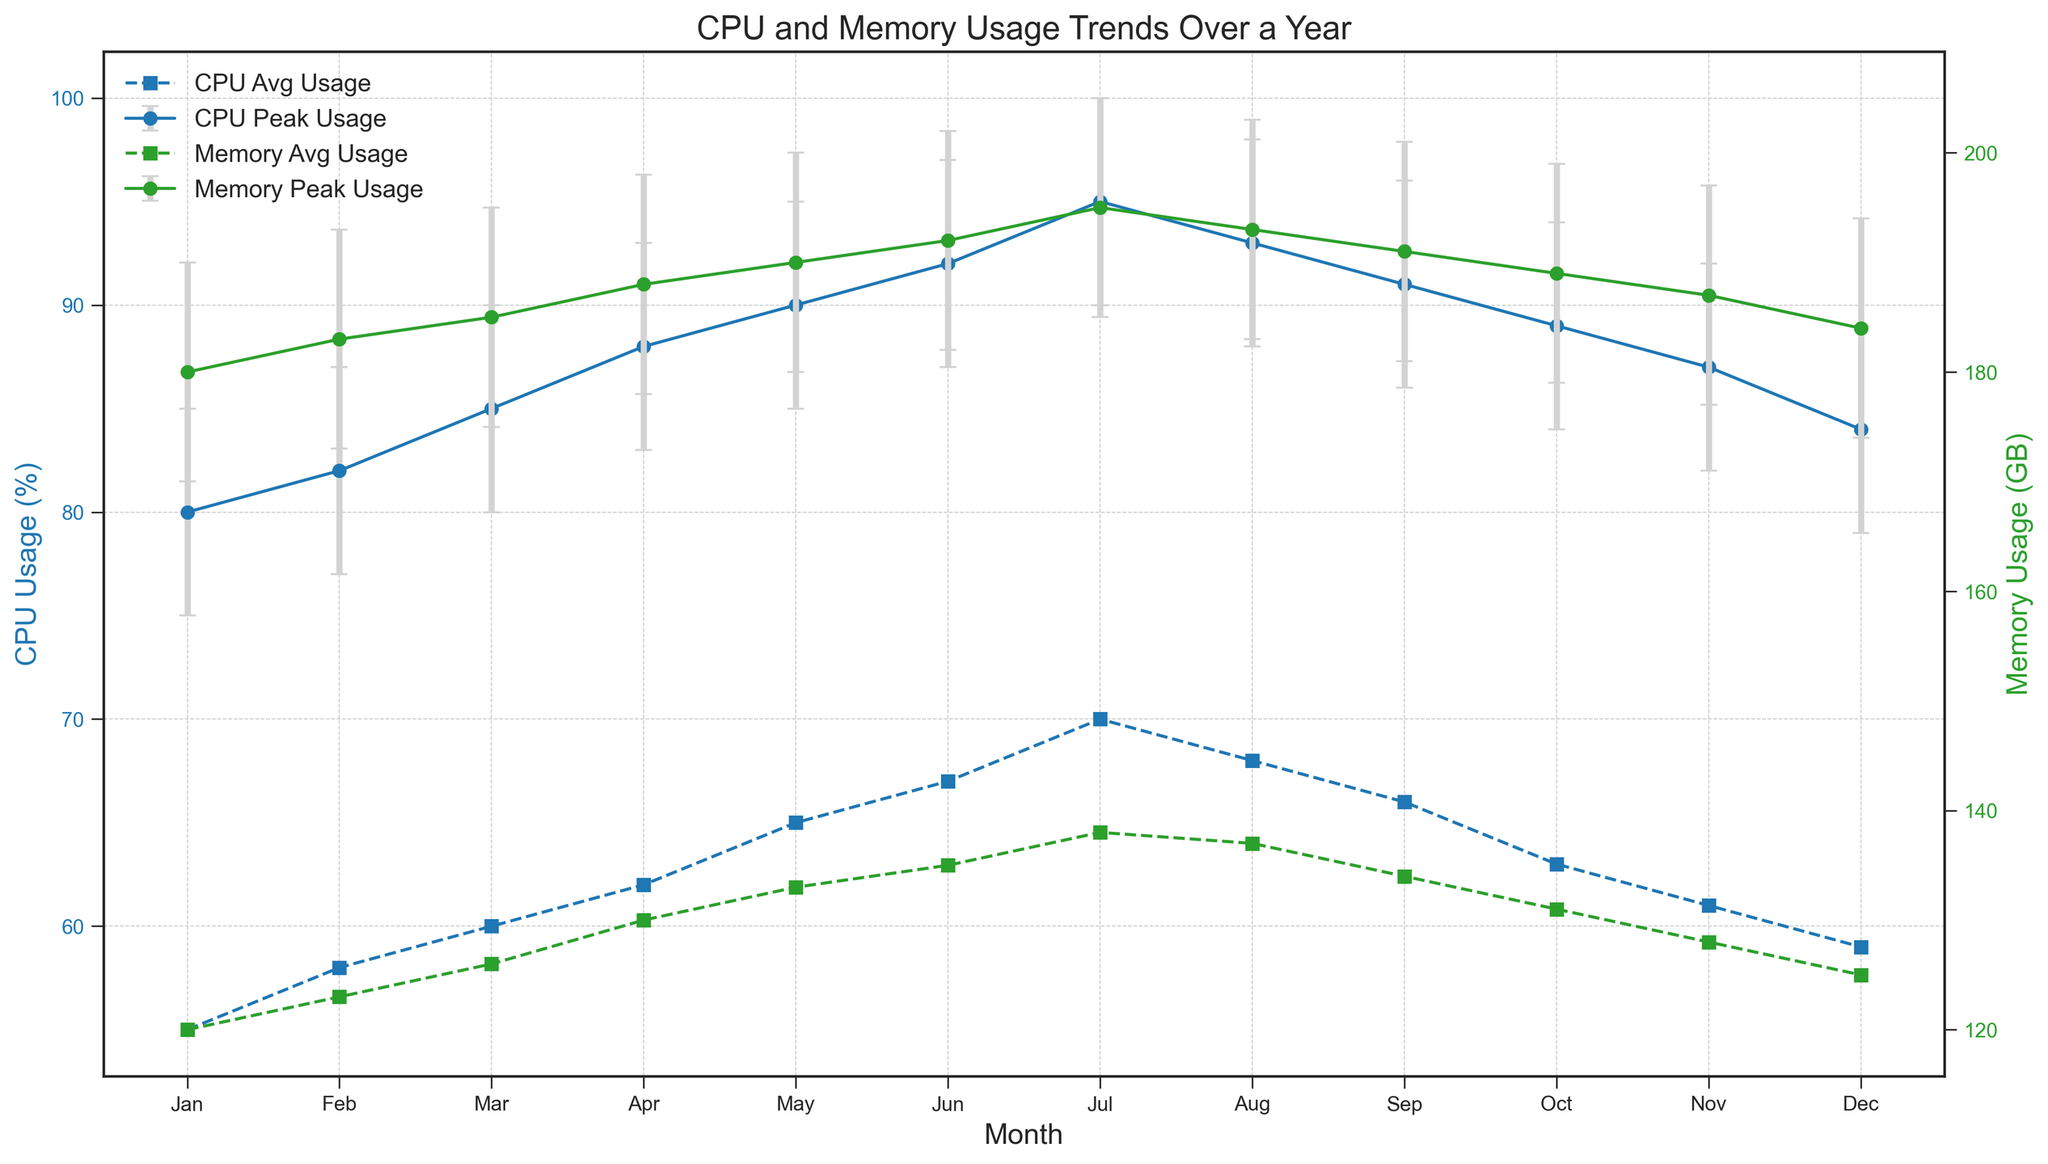What's the peak CPU usage in July? The figure shows CPU peak usage with error bars for each month. July's peak CPU usage is represented by the highest point in July's CPU error bar. According to this bar, the peak usage is 95%.
Answer: 95% Which month had the lower peak memory usage: January or December? We compare the peak memory usage data points for January and December. January's peak is 180 GB, while December's peak is 184 GB, so January had a lower peak memory usage.
Answer: January How much did the average CPU usage increase from January to July? The average CPU usage for January is 55%, and for July, it is 70%. Subtracting January's value from July's: 70% - 55% = 15%. The increase in average CPU usage is 15%.
Answer: 15% What is the range for the confidence interval of CPU peak usage in August? The confidence interval for CPU peak usage in August spans from the lower bound to the upper bound. According to the data, this is from 88% to 98%. The range is calculated as 98% - 88% = 10%.
Answer: 10% Which month shows the smallest confidence interval range for memory peak usage? Confidence intervals are visualized with vertical error bars. To identify the month with the smallest range, we examine each memory peak error bar and compare their lengths. November appears to have the smallest length, indicating a range of 10 GB (187 GB - 177 GB).
Answer: November In which month did the CPU and memory peak usage both decrease compared to the previous month? To detect this, compare monthly peaks in the figure. Identifying the months with such decreases, from October to November, shows both CPU (89% to 87%) and memory peak usage (189 GB to 187 GB) decreased.
Answer: November How does the confidence interval width for CPU peak usage in May compare to the width in September? The data for May's CPU peak CI is 85% to 95%, a width of 10%. September's CI is 86% to 96%, also with a width of 10%. Both intervals span the same width.
Answer: Equal By how much did the memory peak usage increase from April to May? April's peak memory usage is 188 GB, and May's peak is 190 GB. The increase is calculated by the difference: 190 GB - 188 GB = 2 GB.
Answer: 2 GB What trend is observed in the average memory usage from January to December? Observing the series of average memory usage points, from January's 120 GB to December's 125 GB, there is a general increasing trend, with a rise and a peak around mid-year. The usage gradually increases over the months despite some fluctuations.
Answer: Increasing trend Comparing the CPU peak usage in the first half of the year (Jan-Jun) to the second half (Jul-Dec), which half had higher peak usage? Summarizing the peak CPU usages for both halves, the first half runs 80%, 82%, 85%, 88%, 90%, 92%. The second half contains 95%, 93%, 91%, 89%, 87%, 84%. Summing these values: first half = 517%, second half = 539%. The second half has a higher total peak usage.
Answer: Second half 